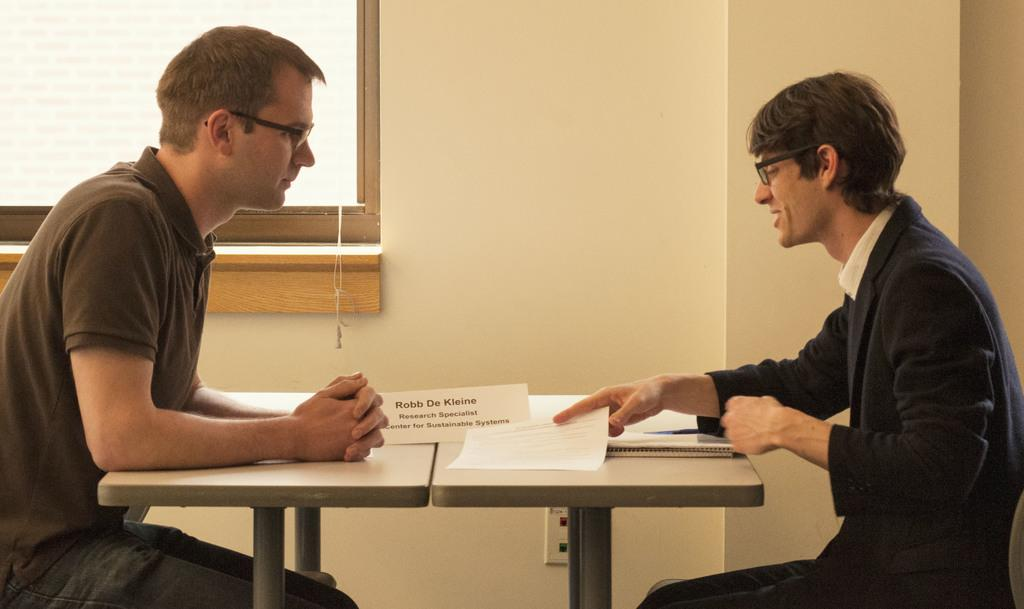How many people are sitting in the image? There are two people sitting in the image. What are the people sitting in front of? The people are sitting in front of a table. What can be seen on the table? There are papers on the table. What is visible in the background of the image? There is a window in the background of the image. What type of scent can be smelled coming from the zoo in the image? There is no zoo present in the image, so it is not possible to determine what scent might be smelled. 